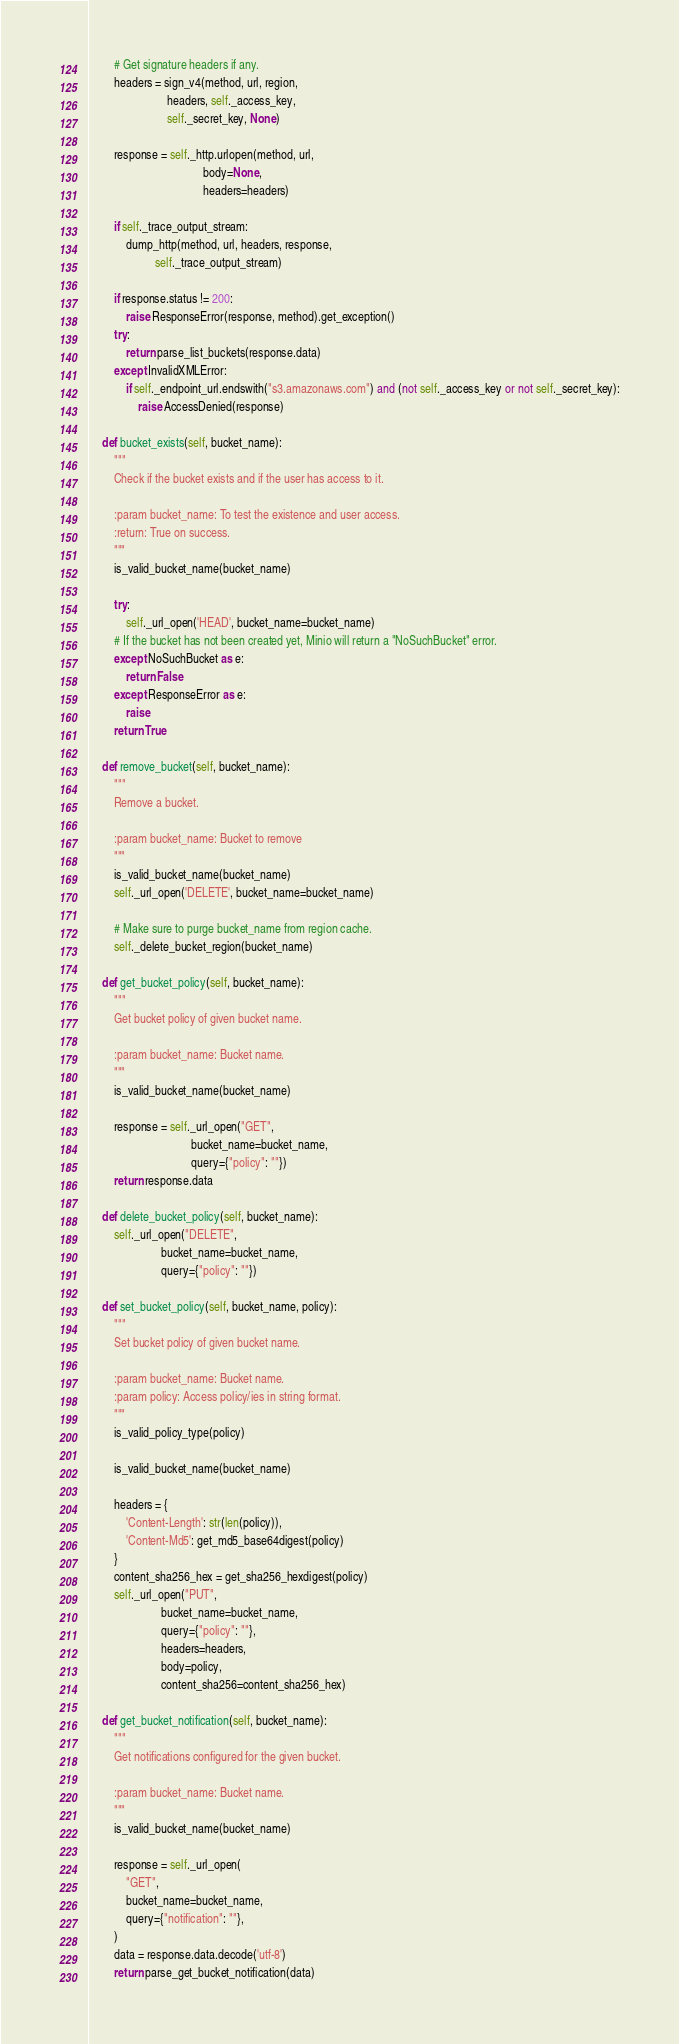<code> <loc_0><loc_0><loc_500><loc_500><_Python_>
        # Get signature headers if any.
        headers = sign_v4(method, url, region,
                          headers, self._access_key,
                          self._secret_key, None)

        response = self._http.urlopen(method, url,
                                      body=None,
                                      headers=headers)

        if self._trace_output_stream:
            dump_http(method, url, headers, response,
                      self._trace_output_stream)

        if response.status != 200:
            raise ResponseError(response, method).get_exception()
        try:
            return parse_list_buckets(response.data)
        except InvalidXMLError:
            if self._endpoint_url.endswith("s3.amazonaws.com") and (not self._access_key or not self._secret_key):
                raise AccessDenied(response)

    def bucket_exists(self, bucket_name):
        """
        Check if the bucket exists and if the user has access to it.

        :param bucket_name: To test the existence and user access.
        :return: True on success.
        """
        is_valid_bucket_name(bucket_name)

        try:
            self._url_open('HEAD', bucket_name=bucket_name)
        # If the bucket has not been created yet, Minio will return a "NoSuchBucket" error.
        except NoSuchBucket as e:
            return False
        except ResponseError as e:
            raise
        return True

    def remove_bucket(self, bucket_name):
        """
        Remove a bucket.

        :param bucket_name: Bucket to remove
        """
        is_valid_bucket_name(bucket_name)
        self._url_open('DELETE', bucket_name=bucket_name)

        # Make sure to purge bucket_name from region cache.
        self._delete_bucket_region(bucket_name)

    def get_bucket_policy(self, bucket_name):
        """
        Get bucket policy of given bucket name.

        :param bucket_name: Bucket name.
        """
        is_valid_bucket_name(bucket_name)

        response = self._url_open("GET",
                                  bucket_name=bucket_name,
                                  query={"policy": ""})
        return response.data

    def delete_bucket_policy(self, bucket_name):
        self._url_open("DELETE",
                        bucket_name=bucket_name,
                        query={"policy": ""})

    def set_bucket_policy(self, bucket_name, policy):
        """
        Set bucket policy of given bucket name.

        :param bucket_name: Bucket name.
        :param policy: Access policy/ies in string format.
        """
        is_valid_policy_type(policy)

        is_valid_bucket_name(bucket_name)

        headers = {
            'Content-Length': str(len(policy)),
            'Content-Md5': get_md5_base64digest(policy)
        }
        content_sha256_hex = get_sha256_hexdigest(policy)
        self._url_open("PUT",
                        bucket_name=bucket_name,
                        query={"policy": ""},
                        headers=headers,
                        body=policy,
                        content_sha256=content_sha256_hex)

    def get_bucket_notification(self, bucket_name):
        """
        Get notifications configured for the given bucket.

        :param bucket_name: Bucket name.
        """
        is_valid_bucket_name(bucket_name)

        response = self._url_open(
            "GET",
            bucket_name=bucket_name,
            query={"notification": ""},
        )
        data = response.data.decode('utf-8')
        return parse_get_bucket_notification(data)
</code> 